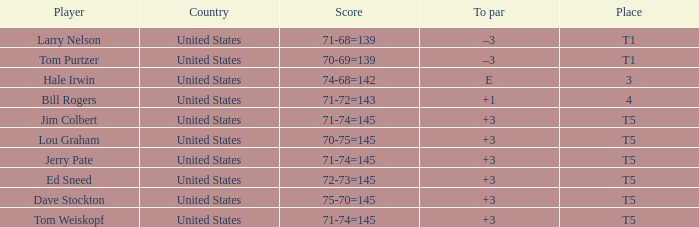What is the to par of player ed sneed, who has a t5 place? 3.0. 